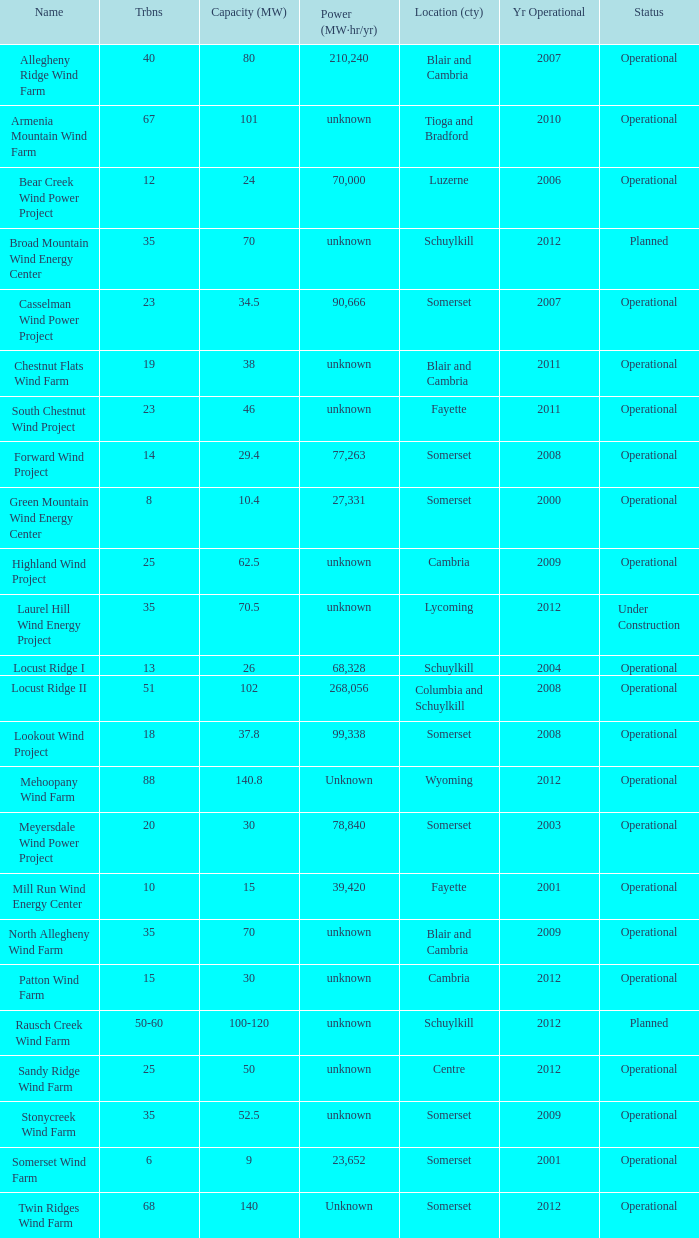What all capacities have turbines between 50-60? 100-120. 